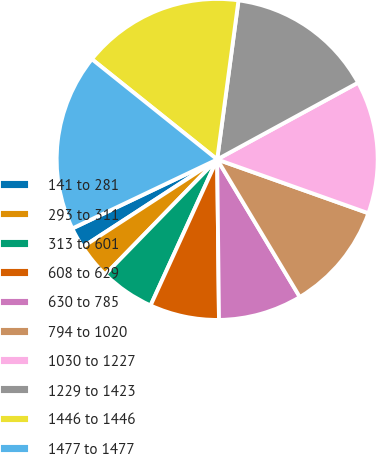Convert chart to OTSL. <chart><loc_0><loc_0><loc_500><loc_500><pie_chart><fcel>141 to 281<fcel>293 to 311<fcel>313 to 601<fcel>608 to 629<fcel>630 to 785<fcel>794 to 1020<fcel>1030 to 1227<fcel>1229 to 1423<fcel>1446 to 1446<fcel>1477 to 1477<nl><fcel>2.1%<fcel>3.54%<fcel>5.47%<fcel>6.99%<fcel>8.43%<fcel>10.95%<fcel>13.38%<fcel>14.94%<fcel>16.38%<fcel>17.82%<nl></chart> 